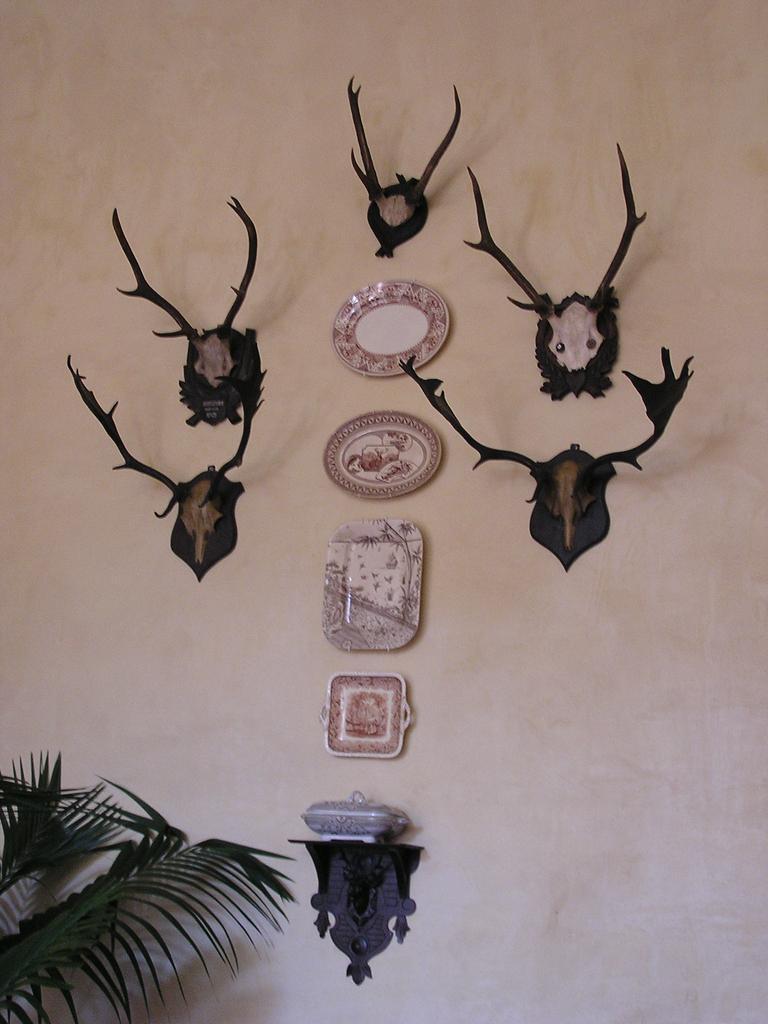How would you summarize this image in a sentence or two? In this image on the wall there are some clocks and some statues, at the bottom there is a plant. 